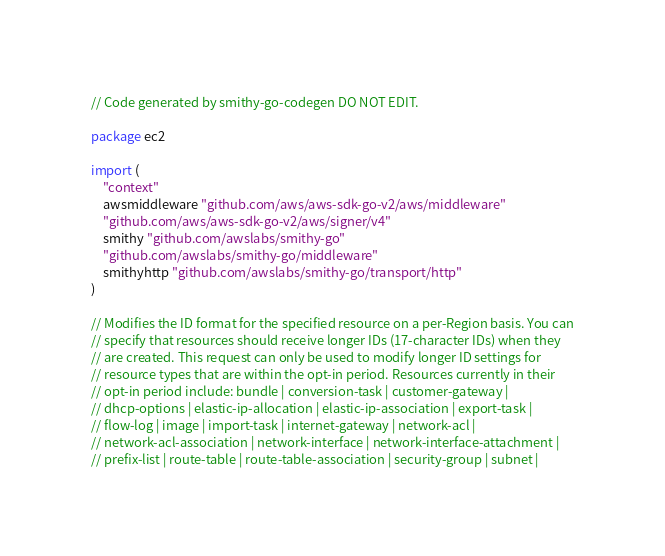Convert code to text. <code><loc_0><loc_0><loc_500><loc_500><_Go_>// Code generated by smithy-go-codegen DO NOT EDIT.

package ec2

import (
	"context"
	awsmiddleware "github.com/aws/aws-sdk-go-v2/aws/middleware"
	"github.com/aws/aws-sdk-go-v2/aws/signer/v4"
	smithy "github.com/awslabs/smithy-go"
	"github.com/awslabs/smithy-go/middleware"
	smithyhttp "github.com/awslabs/smithy-go/transport/http"
)

// Modifies the ID format for the specified resource on a per-Region basis. You can
// specify that resources should receive longer IDs (17-character IDs) when they
// are created. This request can only be used to modify longer ID settings for
// resource types that are within the opt-in period. Resources currently in their
// opt-in period include: bundle | conversion-task | customer-gateway |
// dhcp-options | elastic-ip-allocation | elastic-ip-association | export-task |
// flow-log | image | import-task | internet-gateway | network-acl |
// network-acl-association | network-interface | network-interface-attachment |
// prefix-list | route-table | route-table-association | security-group | subnet |</code> 